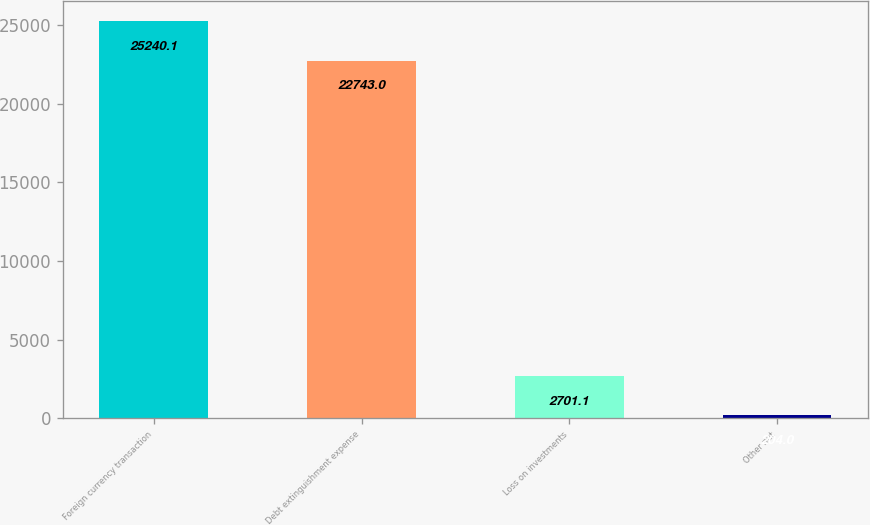Convert chart to OTSL. <chart><loc_0><loc_0><loc_500><loc_500><bar_chart><fcel>Foreign currency transaction<fcel>Debt extinguishment expense<fcel>Loss on investments<fcel>Other net<nl><fcel>25240.1<fcel>22743<fcel>2701.1<fcel>204<nl></chart> 